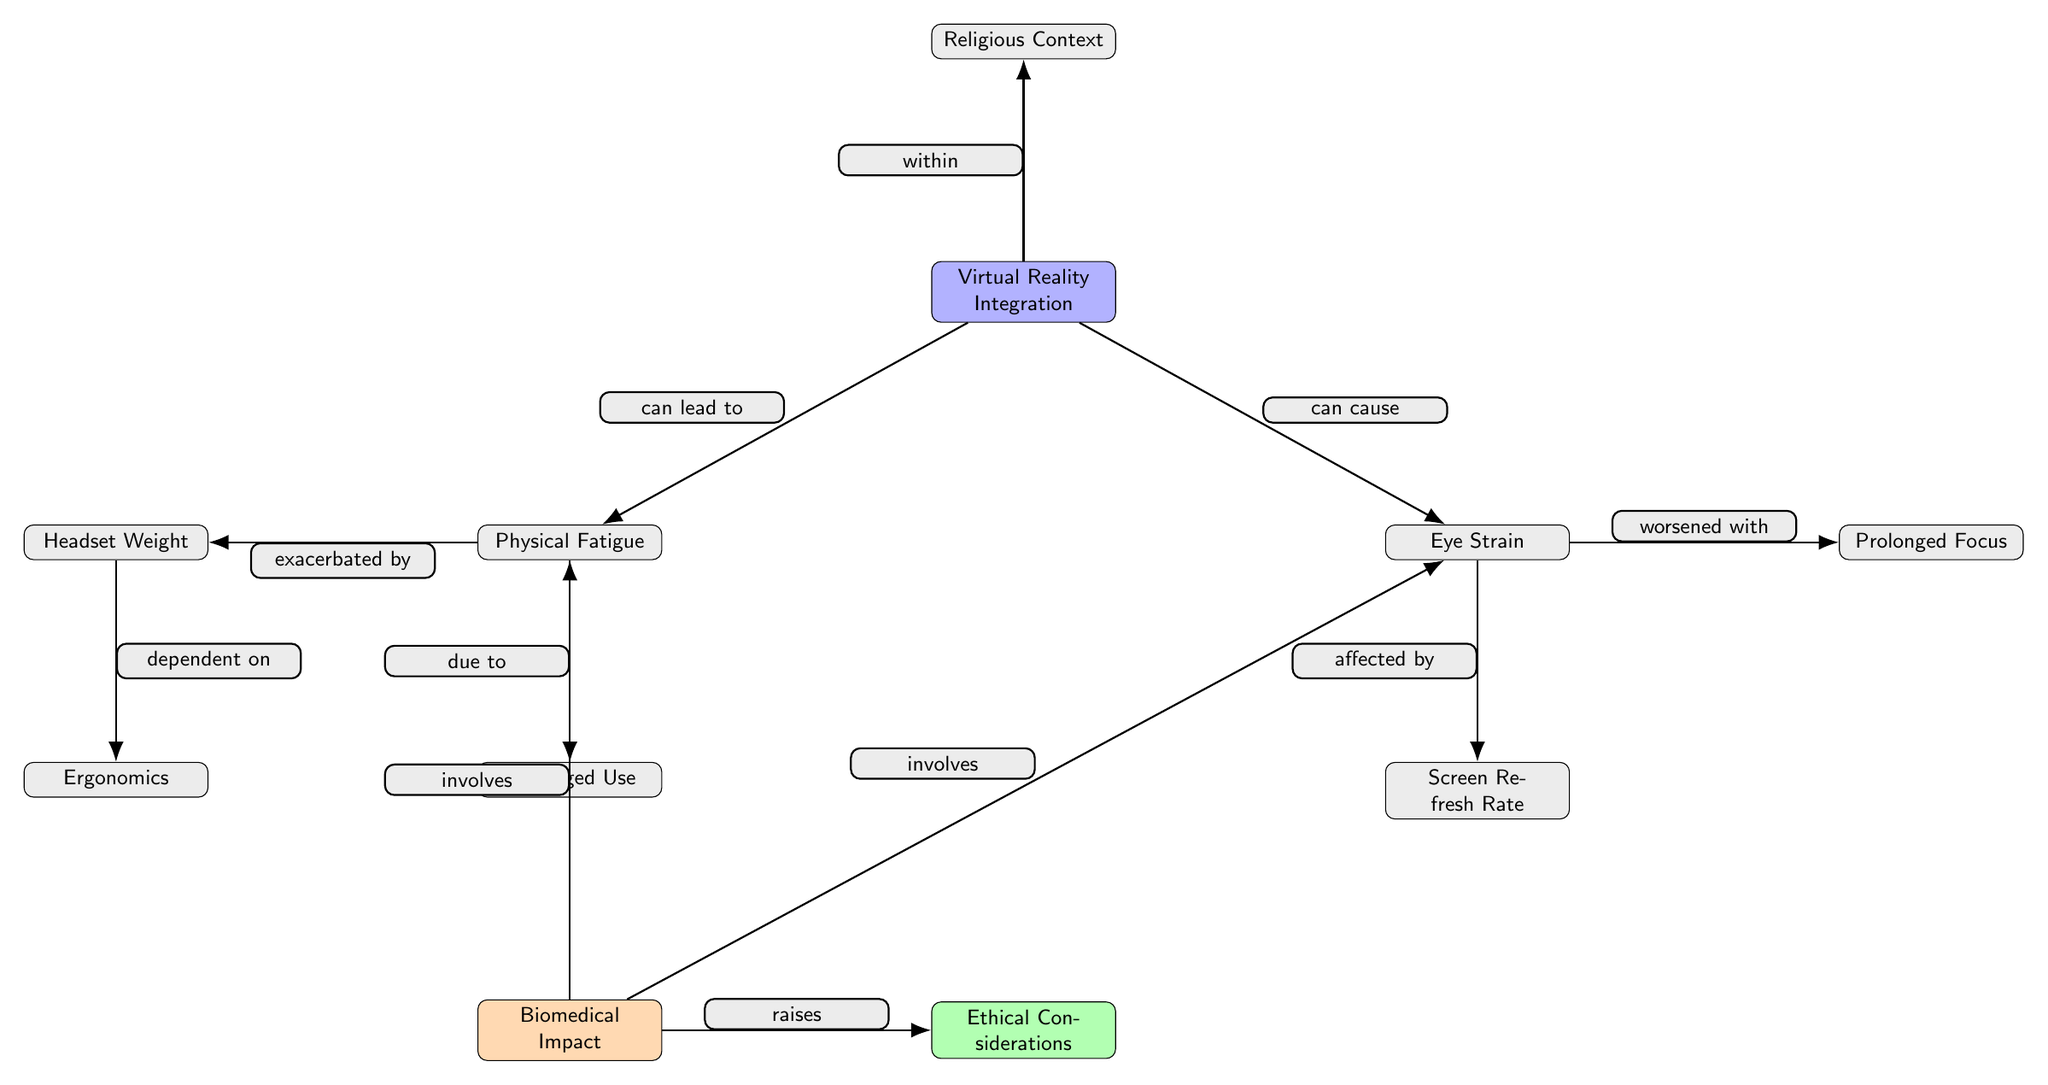What are the two primary biomedical impacts listed in the diagram? The diagram includes two main biomedical impacts: Physical Fatigue and Eye Strain. These impacts arise from integrating virtual reality into religious ceremonies.
Answer: Physical Fatigue, Eye Strain How many total nodes are present in the diagram? Counting all the distinct components (including the main theme and the impacts), there are ten nodes. These include Virtual Reality Integration, Physical Fatigue, Eye Strain, Religious Context, Prolonged Use, Headset Weight, Ergonomics, Screen Refresh Rate, Prolonged Focus, Biomedical Impact, and Ethical Considerations.
Answer: 10 What can prolonged use of VR lead to based on the diagram? The diagram indicates that Prolonged Use can lead to Physical Fatigue, as shown by the arrow from Prolonged Use to Physical Fatigue.
Answer: Physical Fatigue Which factor worsens eye strain according to the diagram? The diagram highlights that Prolonged Focus worsens Eye Strain, indicated by the directed edge from Prolonged Focus to Eye Strain.
Answer: Prolonged Focus In what context is the integration of VR mentioned in the diagram? The diagram specifies that the integration of Virtual Reality occurs within the Religious Context, as indicated by the edge connecting these two nodes.
Answer: Religious Context What ethical consideration is raised by the biomedical impacts shown in the diagram? The diagram points out that the Biomedical Impact raises Ethical Considerations, indicating a relationship between these themes.
Answer: Ethical Considerations Which two factors affect physical fatigue as portrayed in the diagram? Prolonged Use and Headset Weight are the two factors affecting Physical Fatigue, as indicated by the edges connecting these nodes to Physical Fatigue.
Answer: Prolonged Use, Headset Weight How is headset weight dependent on ergonomics in the diagram? The diagram shows that Headset Weight is dependent on Ergonomics, with a directed edge from Ergonomics to Headset Weight indicating this relationship.
Answer: Ergonomics 